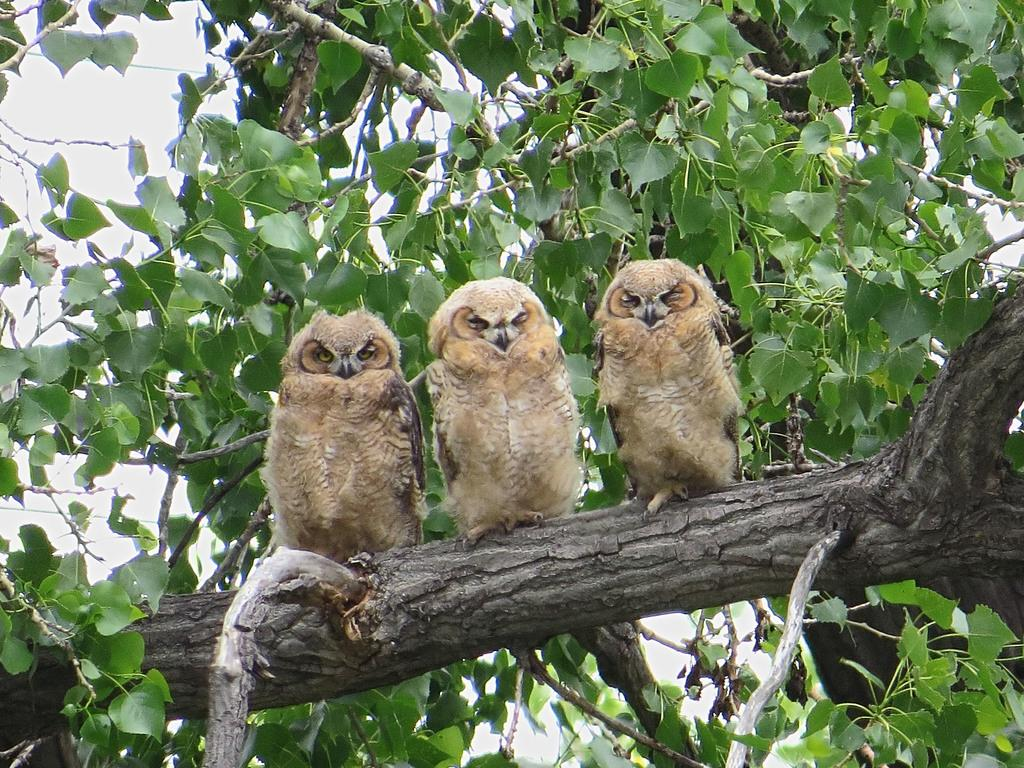What type of animals are in the image? There are owls in the image. Where are the owls located? The owls are on a branch. What can be seen in the background of the image? There are leaves and the sky visible in the background of the image. What type of curve can be seen in the image? There is no curve present in the image; it features owls on a branch with leaves and the sky in the background. 